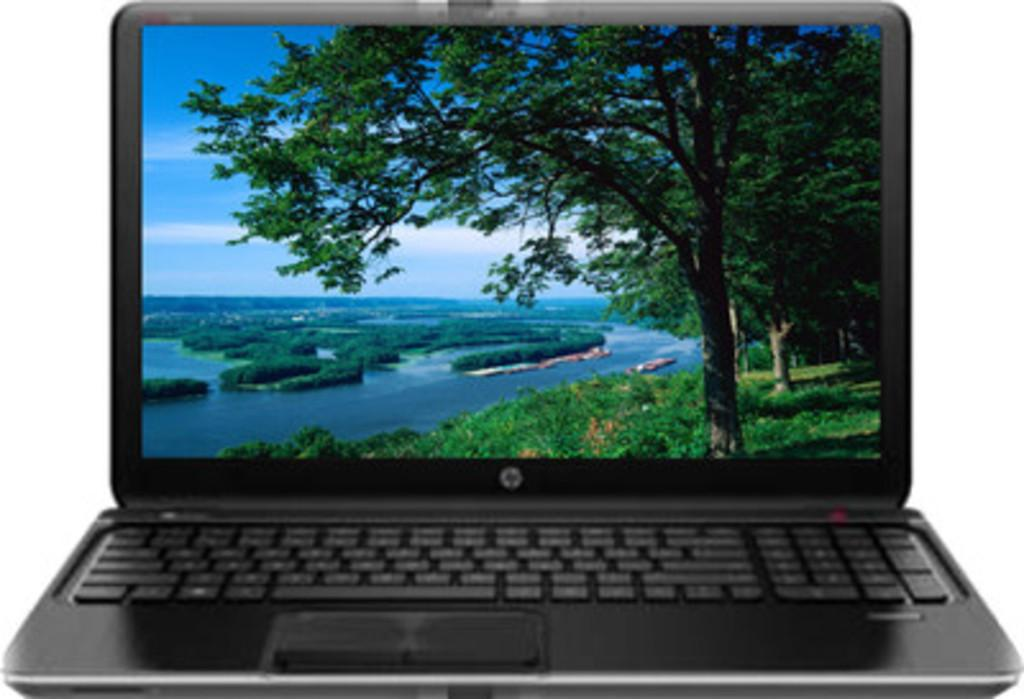What electronic device is visible in the image? There is a laptop in the image. What might the laptop be used for? The laptop might be used for various tasks, such as browsing the internet, working on documents, or streaming media. What type of mint is growing on the roof in the image? There is no roof or mint present in the image; it only features a laptop. 